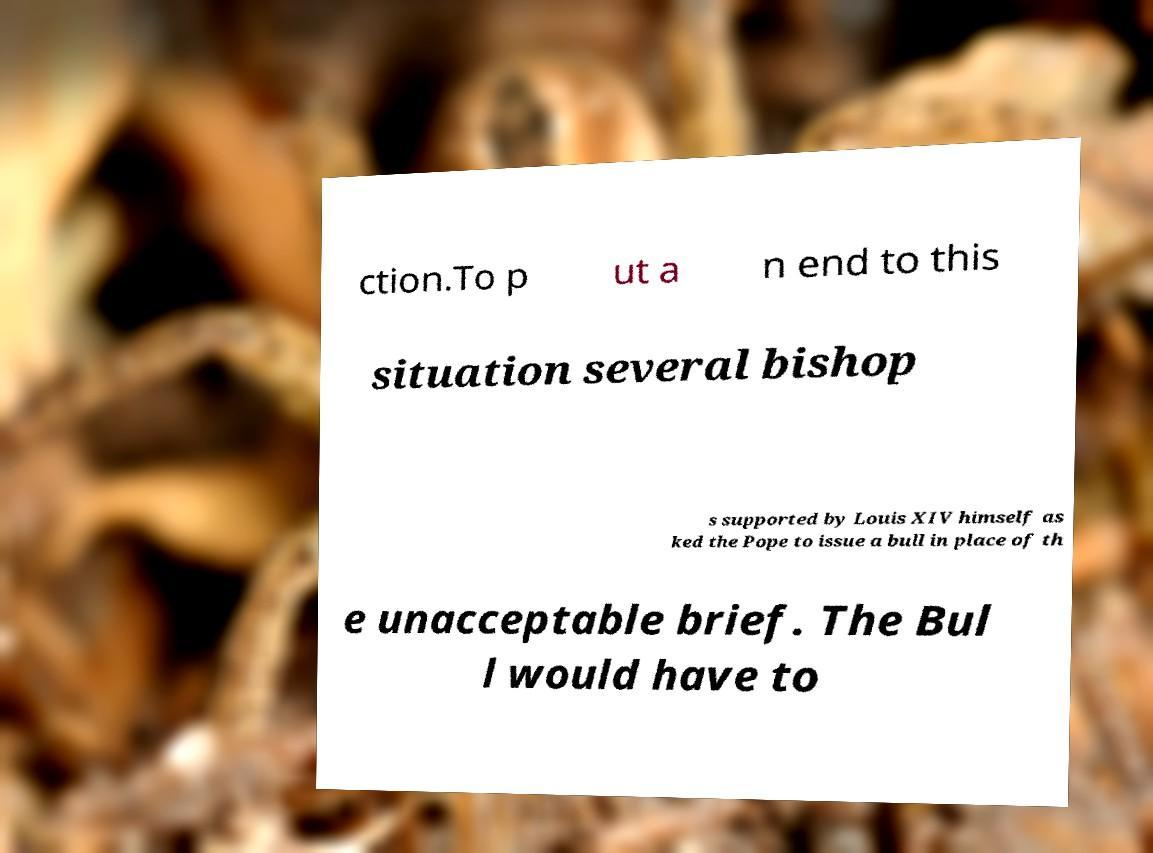Can you read and provide the text displayed in the image?This photo seems to have some interesting text. Can you extract and type it out for me? ction.To p ut a n end to this situation several bishop s supported by Louis XIV himself as ked the Pope to issue a bull in place of th e unacceptable brief. The Bul l would have to 